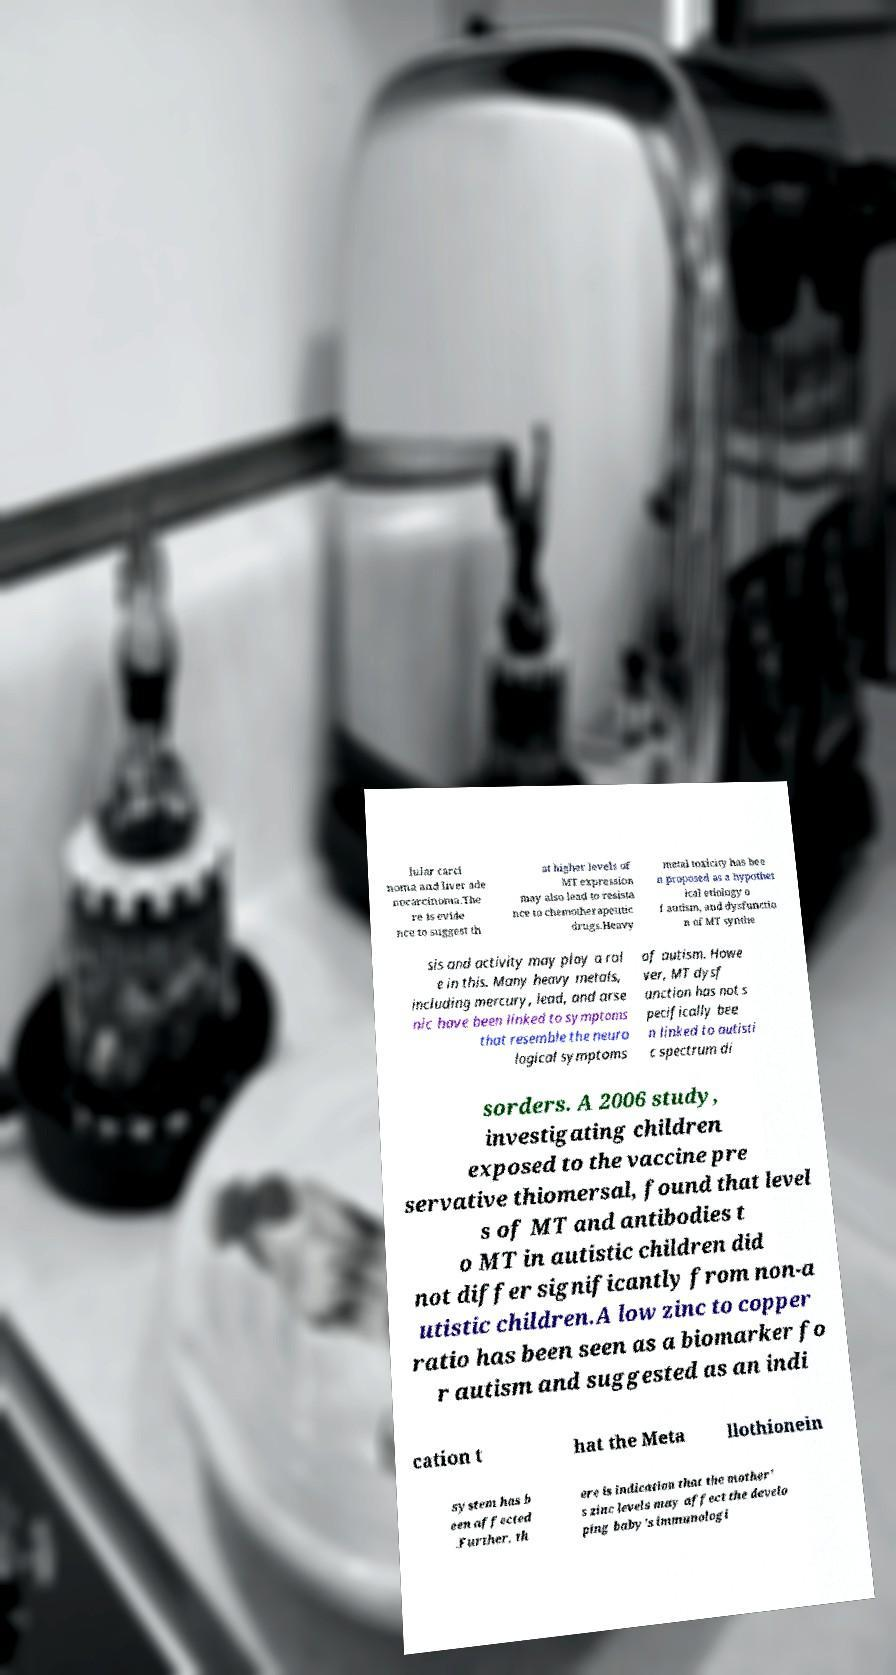Can you accurately transcribe the text from the provided image for me? lular carci noma and liver ade nocarcinoma.The re is evide nce to suggest th at higher levels of MT expression may also lead to resista nce to chemotherapeutic drugs.Heavy metal toxicity has bee n proposed as a hypothet ical etiology o f autism, and dysfunctio n of MT synthe sis and activity may play a rol e in this. Many heavy metals, including mercury, lead, and arse nic have been linked to symptoms that resemble the neuro logical symptoms of autism. Howe ver, MT dysf unction has not s pecifically bee n linked to autisti c spectrum di sorders. A 2006 study, investigating children exposed to the vaccine pre servative thiomersal, found that level s of MT and antibodies t o MT in autistic children did not differ significantly from non-a utistic children.A low zinc to copper ratio has been seen as a biomarker fo r autism and suggested as an indi cation t hat the Meta llothionein system has b een affected .Further, th ere is indication that the mother' s zinc levels may affect the develo ping baby's immunologi 